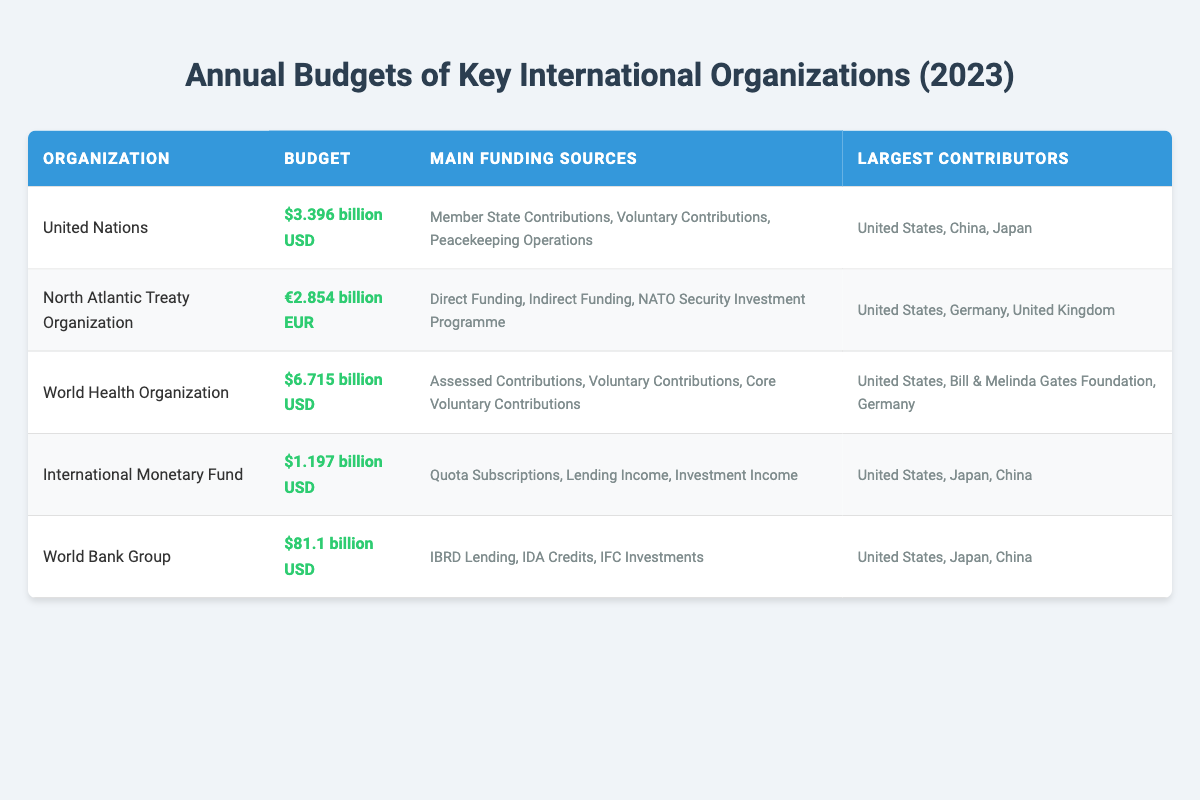What is the budget of the United Nations for 2023? The budget for the United Nations is listed in the table as $3.396 billion USD.
Answer: $3.396 billion USD What are the main funding sources for the World Health Organization? The table indicates that the main funding sources for the World Health Organization are Assessed Contributions, Voluntary Contributions, and Core Voluntary Contributions.
Answer: Assessed Contributions, Voluntary Contributions, Core Voluntary Contributions Which organization has the largest budget? By comparing the budgets listed in the table, the World Bank Group has the largest budget at $81.1 billion USD.
Answer: World Bank Group Is the largest contributor to the NATO budget a member state? According to the table, the United States is listed as the largest contributor to NATO, which is a member state. Therefore, the statement is true.
Answer: Yes What is the total budget in USD of the United Nations and the International Monetary Fund combined? The budget for the United Nations is $3.396 billion USD and the International Monetary Fund is $1.197 billion USD. Adding these two values together gives $3.396 billion + $1.197 billion = $4.593 billion USD.
Answer: $4.593 billion USD What is the budget difference between WHO and UNICEF? The budget for the World Health Organization is $6.715 billion USD, but there is no information given for UNICEF in the table. Thus, the question cannot be answered as asked, leading to "no."
Answer: No Which organization has the smallest budget? The budgets for each organization show that the International Monetary Fund has the smallest budget at $1.197 billion USD.
Answer: International Monetary Fund How many main funding sources does NATO have? The table shows that NATO has three main funding sources: Direct Funding, Indirect Funding, and NATO Security Investment Programme.
Answer: Three Which countries contribute to both the World Bank Group and the International Monetary Fund? Both tables list the United States, Japan, and China as contributors to the World Bank Group and the International Monetary Fund. The common contributors are therefore these three countries.
Answer: United States, Japan, China 